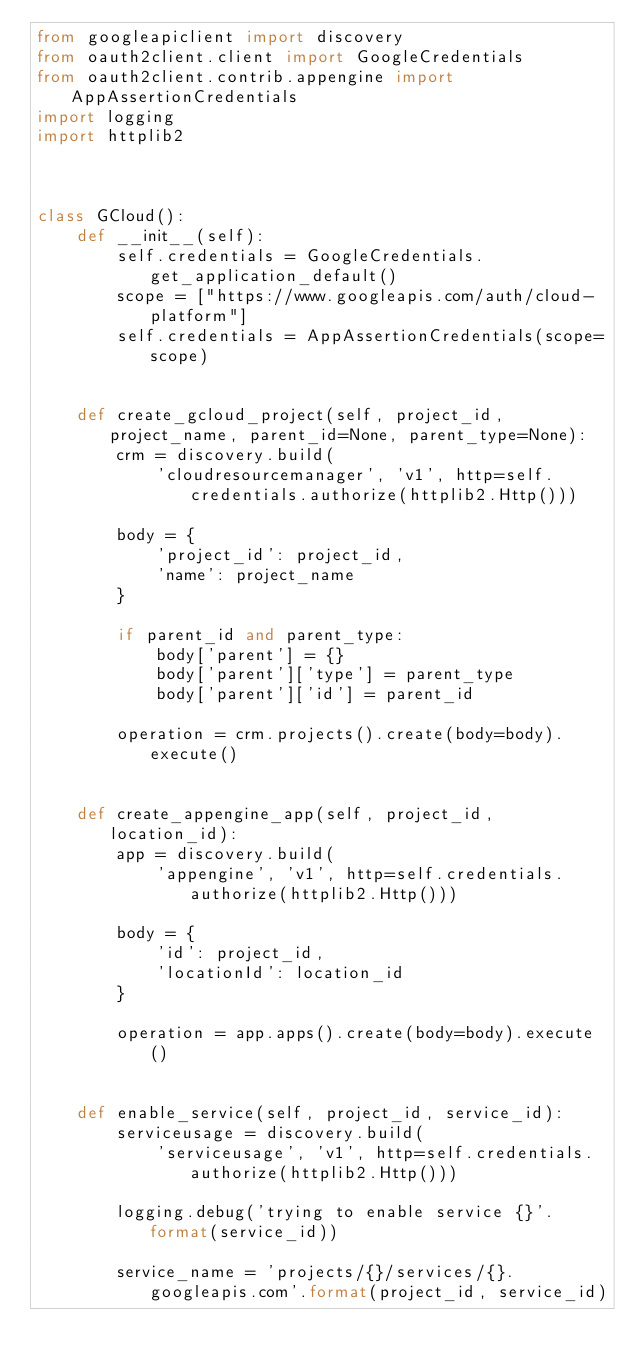<code> <loc_0><loc_0><loc_500><loc_500><_Python_>from googleapiclient import discovery
from oauth2client.client import GoogleCredentials
from oauth2client.contrib.appengine import AppAssertionCredentials
import logging
import httplib2



class GCloud():
    def __init__(self):
        self.credentials = GoogleCredentials.get_application_default()
        scope = ["https://www.googleapis.com/auth/cloud-platform"]
        self.credentials = AppAssertionCredentials(scope=scope)


    def create_gcloud_project(self, project_id, project_name, parent_id=None, parent_type=None):
        crm = discovery.build(
            'cloudresourcemanager', 'v1', http=self.credentials.authorize(httplib2.Http()))

        body = {
            'project_id': project_id,
            'name': project_name
        }

        if parent_id and parent_type:
            body['parent'] = {}
            body['parent']['type'] = parent_type
            body['parent']['id'] = parent_id

        operation = crm.projects().create(body=body).execute()


    def create_appengine_app(self, project_id, location_id):
        app = discovery.build(
            'appengine', 'v1', http=self.credentials.authorize(httplib2.Http()))

        body = {
            'id': project_id,
            'locationId': location_id
        }

        operation = app.apps().create(body=body).execute()
    

    def enable_service(self, project_id, service_id):
        serviceusage = discovery.build(
            'serviceusage', 'v1', http=self.credentials.authorize(httplib2.Http()))

        logging.debug('trying to enable service {}'.format(service_id))

        service_name = 'projects/{}/services/{}.googleapis.com'.format(project_id, service_id)
</code> 